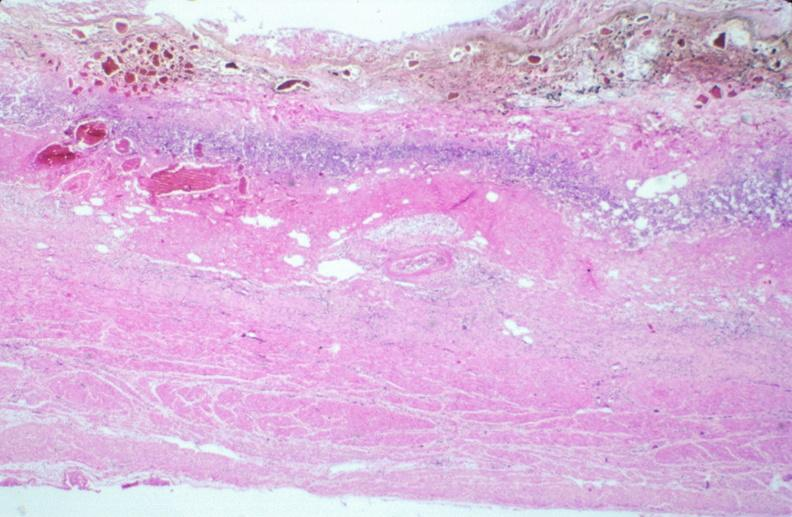what is stomach , necrotizing esophagitis and gastritis , sulfuric acid ingested?
Answer the question using a single word or phrase. As suicide attempt 